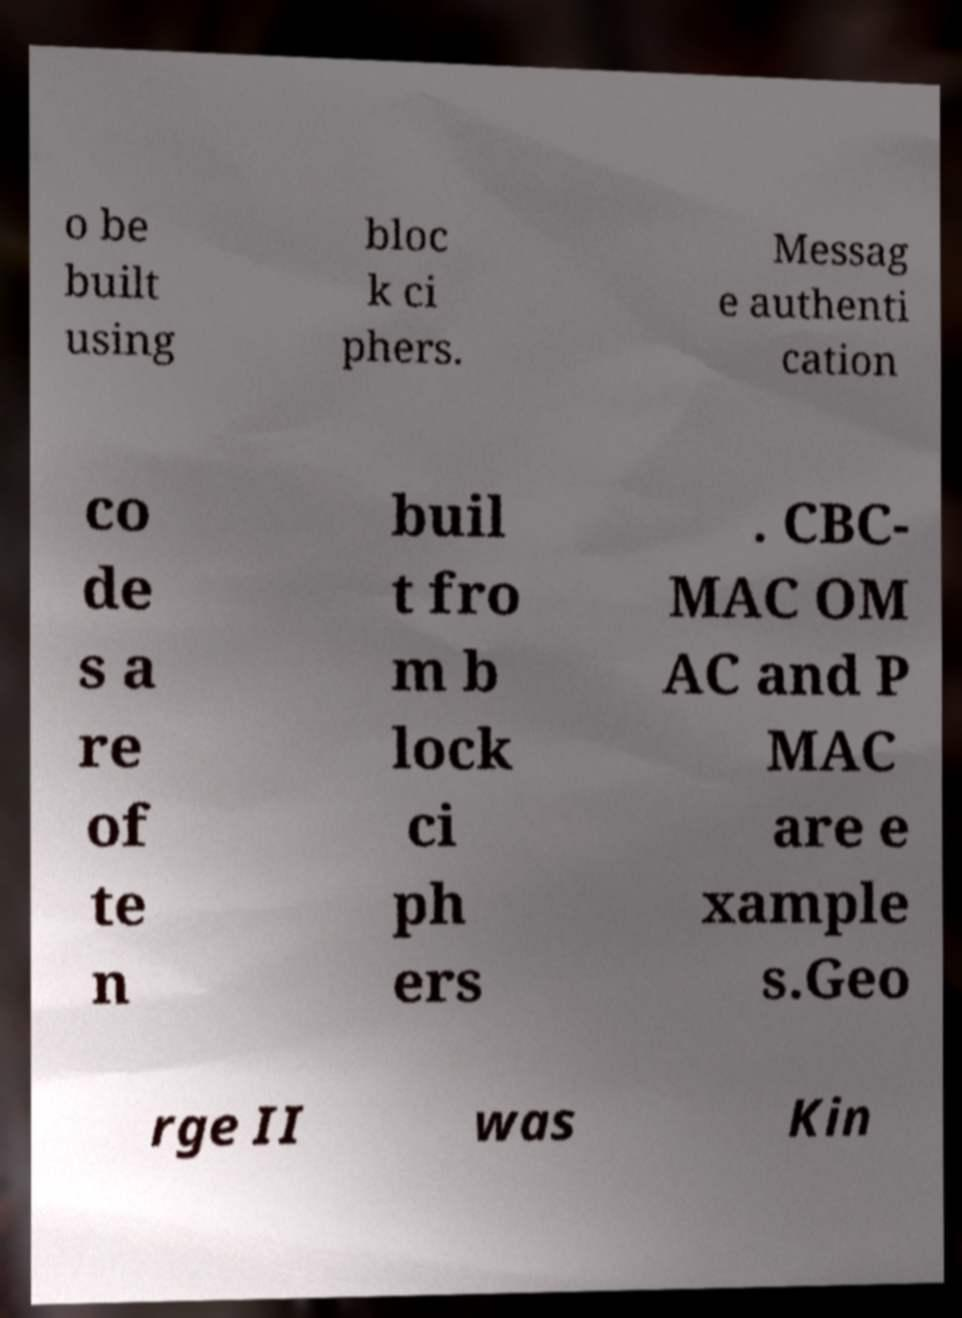Please identify and transcribe the text found in this image. o be built using bloc k ci phers. Messag e authenti cation co de s a re of te n buil t fro m b lock ci ph ers . CBC- MAC OM AC and P MAC are e xample s.Geo rge II was Kin 